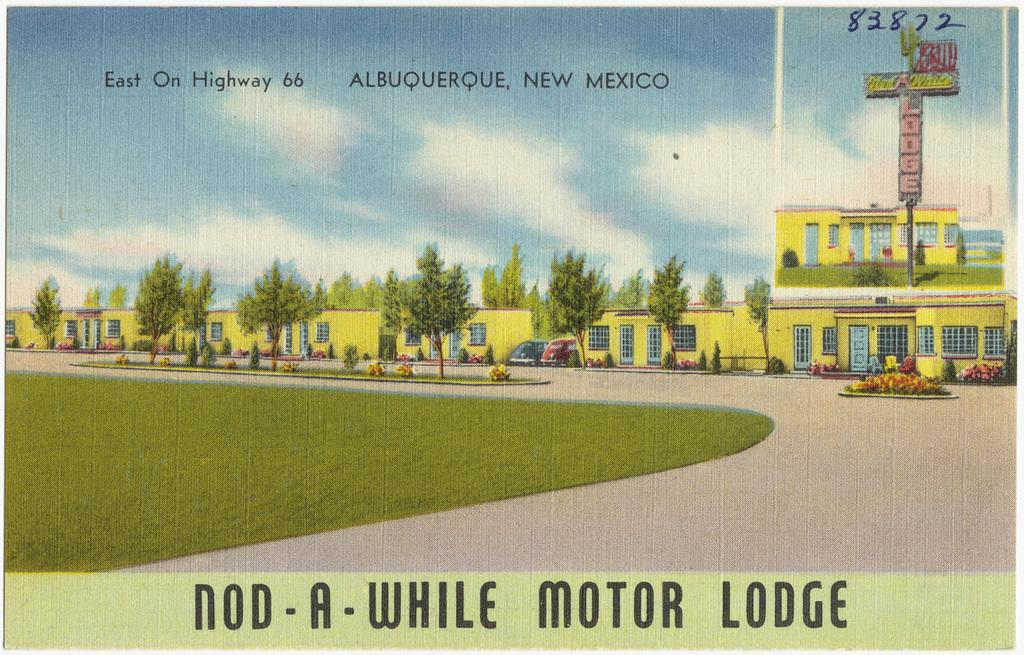<image>
Provide a brief description of the given image. A post card from the Nod a While Motor Lodge. 